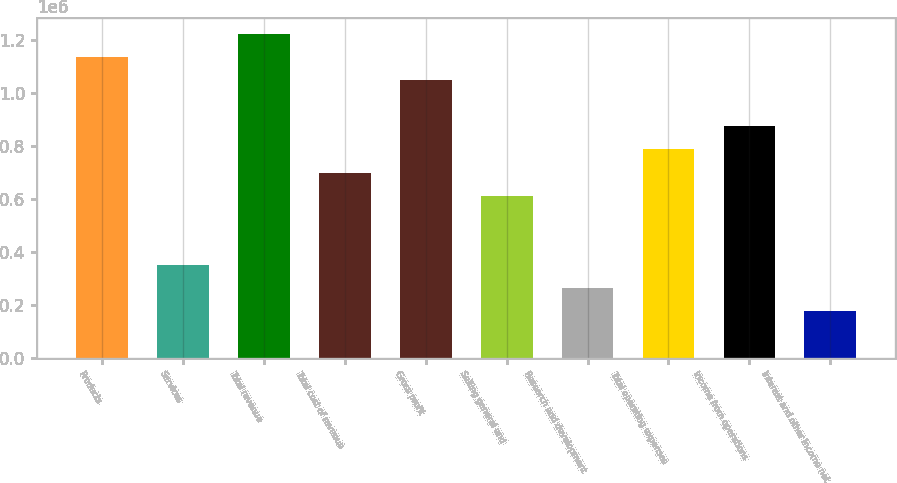Convert chart. <chart><loc_0><loc_0><loc_500><loc_500><bar_chart><fcel>Products<fcel>Services<fcel>Total revenue<fcel>Total cost of revenue<fcel>Gross profit<fcel>Selling general and<fcel>Research and development<fcel>Total operating expenses<fcel>Income from operations<fcel>Interest and other income net<nl><fcel>1.13739e+06<fcel>349971<fcel>1.22488e+06<fcel>699936<fcel>1.0499e+06<fcel>612445<fcel>262479<fcel>787428<fcel>874919<fcel>174988<nl></chart> 